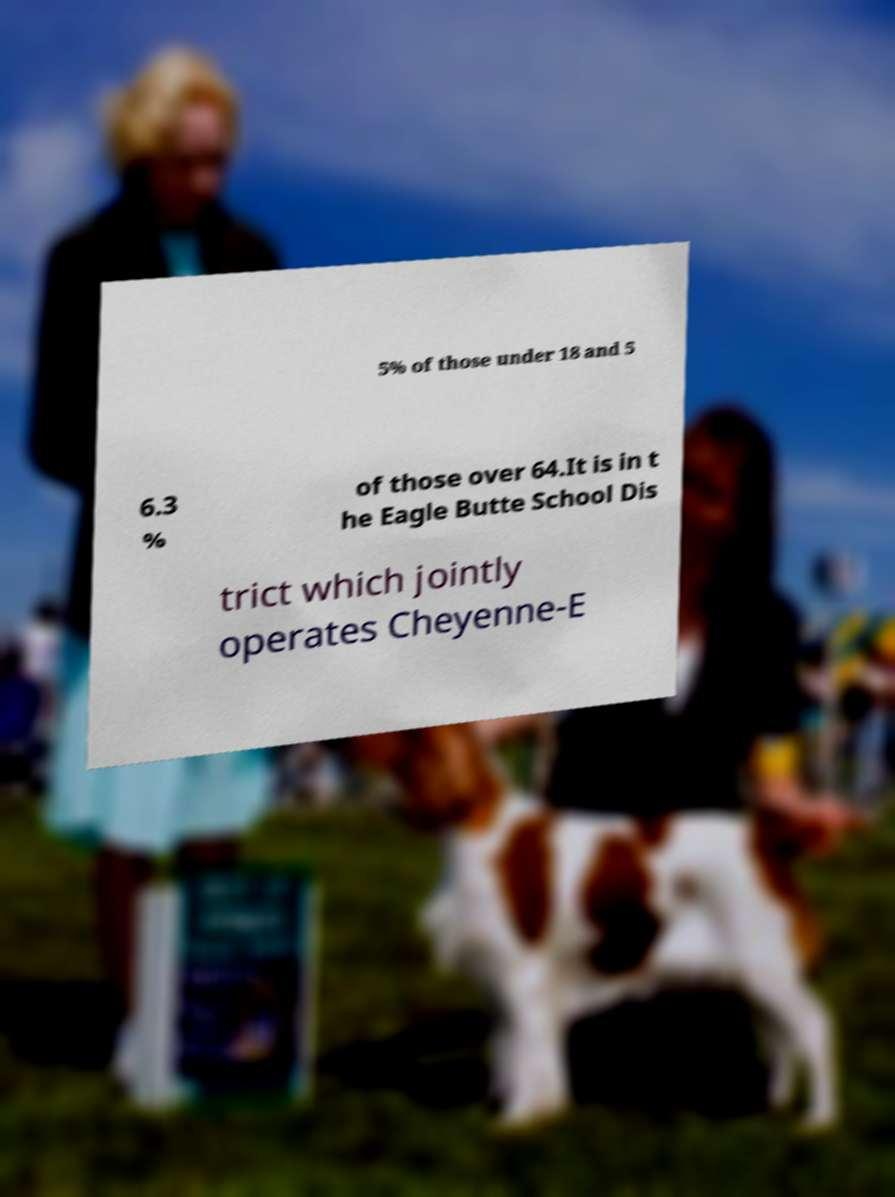Please identify and transcribe the text found in this image. 5% of those under 18 and 5 6.3 % of those over 64.It is in t he Eagle Butte School Dis trict which jointly operates Cheyenne-E 